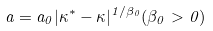<formula> <loc_0><loc_0><loc_500><loc_500>a = a _ { 0 } | \kappa ^ { * } - \kappa | ^ { 1 / \beta _ { 0 } } ( \beta _ { 0 } > 0 )</formula> 